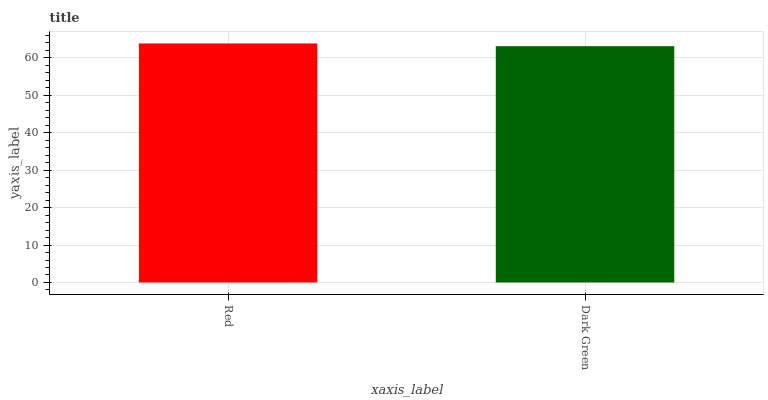Is Dark Green the minimum?
Answer yes or no. Yes. Is Red the maximum?
Answer yes or no. Yes. Is Dark Green the maximum?
Answer yes or no. No. Is Red greater than Dark Green?
Answer yes or no. Yes. Is Dark Green less than Red?
Answer yes or no. Yes. Is Dark Green greater than Red?
Answer yes or no. No. Is Red less than Dark Green?
Answer yes or no. No. Is Red the high median?
Answer yes or no. Yes. Is Dark Green the low median?
Answer yes or no. Yes. Is Dark Green the high median?
Answer yes or no. No. Is Red the low median?
Answer yes or no. No. 